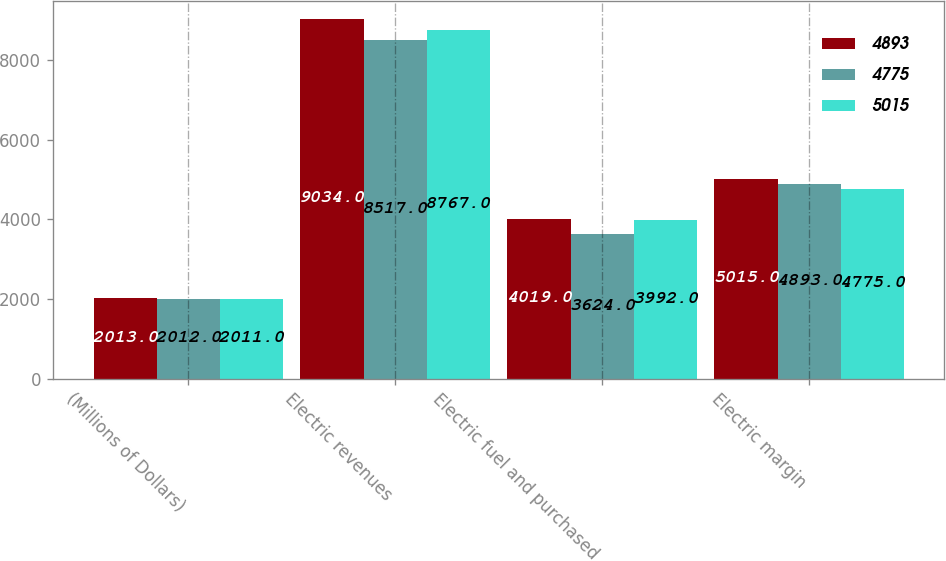Convert chart. <chart><loc_0><loc_0><loc_500><loc_500><stacked_bar_chart><ecel><fcel>(Millions of Dollars)<fcel>Electric revenues<fcel>Electric fuel and purchased<fcel>Electric margin<nl><fcel>4893<fcel>2013<fcel>9034<fcel>4019<fcel>5015<nl><fcel>4775<fcel>2012<fcel>8517<fcel>3624<fcel>4893<nl><fcel>5015<fcel>2011<fcel>8767<fcel>3992<fcel>4775<nl></chart> 